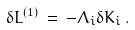<formula> <loc_0><loc_0><loc_500><loc_500>\delta L ^ { ( 1 ) } \, = \, - \Lambda _ { i } \delta K _ { i } \, .</formula> 